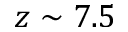Convert formula to latex. <formula><loc_0><loc_0><loc_500><loc_500>z \sim 7 . 5</formula> 